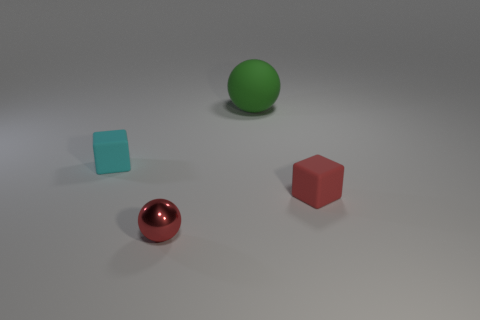Subtract 1 balls. How many balls are left? 1 Add 4 large purple rubber objects. How many objects exist? 8 Subtract all cyan blocks. How many blocks are left? 1 Add 1 big rubber things. How many big rubber things exist? 2 Subtract 0 blue blocks. How many objects are left? 4 Subtract all gray blocks. Subtract all brown cylinders. How many blocks are left? 2 Subtract all yellow blocks. How many gray balls are left? 0 Subtract all small green balls. Subtract all cyan blocks. How many objects are left? 3 Add 2 small cyan blocks. How many small cyan blocks are left? 3 